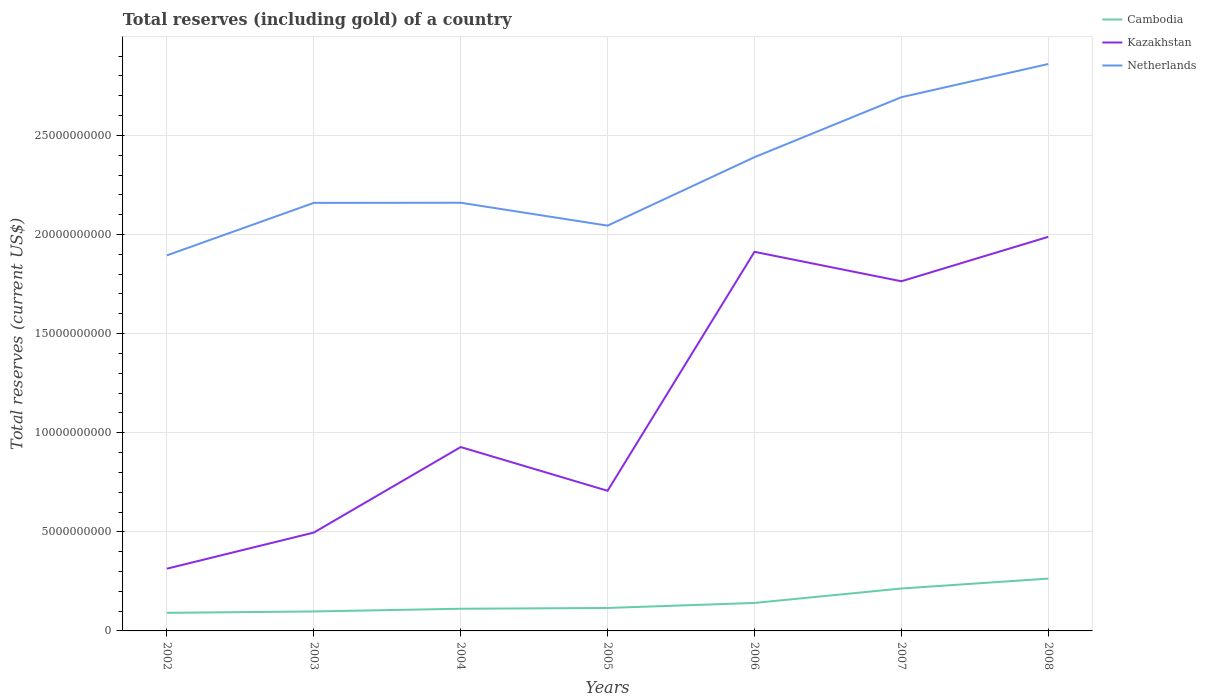How many different coloured lines are there?
Keep it short and to the point. 3. Does the line corresponding to Cambodia intersect with the line corresponding to Netherlands?
Offer a very short reply. No. Across all years, what is the maximum total reserves (including gold) in Kazakhstan?
Keep it short and to the point. 3.14e+09. What is the total total reserves (including gold) in Cambodia in the graph?
Offer a terse response. -2.93e+08. What is the difference between the highest and the second highest total reserves (including gold) in Kazakhstan?
Provide a succinct answer. 1.67e+1. What is the difference between the highest and the lowest total reserves (including gold) in Netherlands?
Give a very brief answer. 3. How many years are there in the graph?
Make the answer very short. 7. What is the difference between two consecutive major ticks on the Y-axis?
Offer a very short reply. 5.00e+09. Are the values on the major ticks of Y-axis written in scientific E-notation?
Offer a very short reply. No. Where does the legend appear in the graph?
Offer a terse response. Top right. What is the title of the graph?
Keep it short and to the point. Total reserves (including gold) of a country. Does "Barbados" appear as one of the legend labels in the graph?
Provide a succinct answer. No. What is the label or title of the X-axis?
Offer a terse response. Years. What is the label or title of the Y-axis?
Your answer should be compact. Total reserves (current US$). What is the Total reserves (current US$) in Cambodia in 2002?
Your response must be concise. 9.13e+08. What is the Total reserves (current US$) of Kazakhstan in 2002?
Keep it short and to the point. 3.14e+09. What is the Total reserves (current US$) in Netherlands in 2002?
Offer a terse response. 1.89e+1. What is the Total reserves (current US$) in Cambodia in 2003?
Your answer should be compact. 9.82e+08. What is the Total reserves (current US$) of Kazakhstan in 2003?
Your answer should be compact. 4.96e+09. What is the Total reserves (current US$) of Netherlands in 2003?
Your answer should be compact. 2.16e+1. What is the Total reserves (current US$) in Cambodia in 2004?
Provide a succinct answer. 1.12e+09. What is the Total reserves (current US$) of Kazakhstan in 2004?
Offer a very short reply. 9.28e+09. What is the Total reserves (current US$) in Netherlands in 2004?
Provide a short and direct response. 2.16e+1. What is the Total reserves (current US$) in Cambodia in 2005?
Make the answer very short. 1.16e+09. What is the Total reserves (current US$) of Kazakhstan in 2005?
Give a very brief answer. 7.07e+09. What is the Total reserves (current US$) of Netherlands in 2005?
Keep it short and to the point. 2.04e+1. What is the Total reserves (current US$) of Cambodia in 2006?
Give a very brief answer. 1.41e+09. What is the Total reserves (current US$) in Kazakhstan in 2006?
Your answer should be very brief. 1.91e+1. What is the Total reserves (current US$) in Netherlands in 2006?
Your answer should be very brief. 2.39e+1. What is the Total reserves (current US$) in Cambodia in 2007?
Make the answer very short. 2.14e+09. What is the Total reserves (current US$) of Kazakhstan in 2007?
Provide a succinct answer. 1.76e+1. What is the Total reserves (current US$) in Netherlands in 2007?
Your answer should be very brief. 2.69e+1. What is the Total reserves (current US$) in Cambodia in 2008?
Keep it short and to the point. 2.64e+09. What is the Total reserves (current US$) of Kazakhstan in 2008?
Ensure brevity in your answer.  1.99e+1. What is the Total reserves (current US$) of Netherlands in 2008?
Your response must be concise. 2.86e+1. Across all years, what is the maximum Total reserves (current US$) in Cambodia?
Provide a short and direct response. 2.64e+09. Across all years, what is the maximum Total reserves (current US$) in Kazakhstan?
Make the answer very short. 1.99e+1. Across all years, what is the maximum Total reserves (current US$) of Netherlands?
Give a very brief answer. 2.86e+1. Across all years, what is the minimum Total reserves (current US$) of Cambodia?
Offer a very short reply. 9.13e+08. Across all years, what is the minimum Total reserves (current US$) of Kazakhstan?
Your answer should be very brief. 3.14e+09. Across all years, what is the minimum Total reserves (current US$) in Netherlands?
Keep it short and to the point. 1.89e+1. What is the total Total reserves (current US$) of Cambodia in the graph?
Your answer should be very brief. 1.04e+1. What is the total Total reserves (current US$) of Kazakhstan in the graph?
Keep it short and to the point. 8.11e+1. What is the total Total reserves (current US$) of Netherlands in the graph?
Keep it short and to the point. 1.62e+11. What is the difference between the Total reserves (current US$) of Cambodia in 2002 and that in 2003?
Keep it short and to the point. -6.92e+07. What is the difference between the Total reserves (current US$) in Kazakhstan in 2002 and that in 2003?
Provide a short and direct response. -1.82e+09. What is the difference between the Total reserves (current US$) of Netherlands in 2002 and that in 2003?
Give a very brief answer. -2.65e+09. What is the difference between the Total reserves (current US$) in Cambodia in 2002 and that in 2004?
Ensure brevity in your answer.  -2.05e+08. What is the difference between the Total reserves (current US$) in Kazakhstan in 2002 and that in 2004?
Provide a succinct answer. -6.14e+09. What is the difference between the Total reserves (current US$) in Netherlands in 2002 and that in 2004?
Your answer should be compact. -2.65e+09. What is the difference between the Total reserves (current US$) of Cambodia in 2002 and that in 2005?
Provide a succinct answer. -2.45e+08. What is the difference between the Total reserves (current US$) in Kazakhstan in 2002 and that in 2005?
Offer a very short reply. -3.93e+09. What is the difference between the Total reserves (current US$) in Netherlands in 2002 and that in 2005?
Offer a terse response. -1.50e+09. What is the difference between the Total reserves (current US$) of Cambodia in 2002 and that in 2006?
Your answer should be very brief. -4.98e+08. What is the difference between the Total reserves (current US$) of Kazakhstan in 2002 and that in 2006?
Offer a very short reply. -1.60e+1. What is the difference between the Total reserves (current US$) of Netherlands in 2002 and that in 2006?
Provide a short and direct response. -4.95e+09. What is the difference between the Total reserves (current US$) of Cambodia in 2002 and that in 2007?
Provide a succinct answer. -1.23e+09. What is the difference between the Total reserves (current US$) of Kazakhstan in 2002 and that in 2007?
Provide a short and direct response. -1.45e+1. What is the difference between the Total reserves (current US$) in Netherlands in 2002 and that in 2007?
Provide a succinct answer. -7.98e+09. What is the difference between the Total reserves (current US$) in Cambodia in 2002 and that in 2008?
Provide a succinct answer. -1.73e+09. What is the difference between the Total reserves (current US$) of Kazakhstan in 2002 and that in 2008?
Your answer should be compact. -1.67e+1. What is the difference between the Total reserves (current US$) in Netherlands in 2002 and that in 2008?
Provide a succinct answer. -9.65e+09. What is the difference between the Total reserves (current US$) in Cambodia in 2003 and that in 2004?
Your response must be concise. -1.36e+08. What is the difference between the Total reserves (current US$) in Kazakhstan in 2003 and that in 2004?
Provide a short and direct response. -4.31e+09. What is the difference between the Total reserves (current US$) of Netherlands in 2003 and that in 2004?
Your answer should be very brief. -6.46e+06. What is the difference between the Total reserves (current US$) in Cambodia in 2003 and that in 2005?
Your response must be concise. -1.76e+08. What is the difference between the Total reserves (current US$) in Kazakhstan in 2003 and that in 2005?
Offer a terse response. -2.11e+09. What is the difference between the Total reserves (current US$) in Netherlands in 2003 and that in 2005?
Keep it short and to the point. 1.15e+09. What is the difference between the Total reserves (current US$) in Cambodia in 2003 and that in 2006?
Offer a very short reply. -4.29e+08. What is the difference between the Total reserves (current US$) of Kazakhstan in 2003 and that in 2006?
Give a very brief answer. -1.42e+1. What is the difference between the Total reserves (current US$) of Netherlands in 2003 and that in 2006?
Offer a very short reply. -2.31e+09. What is the difference between the Total reserves (current US$) of Cambodia in 2003 and that in 2007?
Your answer should be compact. -1.16e+09. What is the difference between the Total reserves (current US$) of Kazakhstan in 2003 and that in 2007?
Provide a succinct answer. -1.27e+1. What is the difference between the Total reserves (current US$) in Netherlands in 2003 and that in 2007?
Ensure brevity in your answer.  -5.33e+09. What is the difference between the Total reserves (current US$) of Cambodia in 2003 and that in 2008?
Make the answer very short. -1.66e+09. What is the difference between the Total reserves (current US$) of Kazakhstan in 2003 and that in 2008?
Offer a very short reply. -1.49e+1. What is the difference between the Total reserves (current US$) in Netherlands in 2003 and that in 2008?
Provide a succinct answer. -7.01e+09. What is the difference between the Total reserves (current US$) in Cambodia in 2004 and that in 2005?
Keep it short and to the point. -3.98e+07. What is the difference between the Total reserves (current US$) in Kazakhstan in 2004 and that in 2005?
Keep it short and to the point. 2.21e+09. What is the difference between the Total reserves (current US$) in Netherlands in 2004 and that in 2005?
Provide a short and direct response. 1.16e+09. What is the difference between the Total reserves (current US$) of Cambodia in 2004 and that in 2006?
Ensure brevity in your answer.  -2.93e+08. What is the difference between the Total reserves (current US$) in Kazakhstan in 2004 and that in 2006?
Make the answer very short. -9.85e+09. What is the difference between the Total reserves (current US$) in Netherlands in 2004 and that in 2006?
Ensure brevity in your answer.  -2.30e+09. What is the difference between the Total reserves (current US$) in Cambodia in 2004 and that in 2007?
Your response must be concise. -1.02e+09. What is the difference between the Total reserves (current US$) of Kazakhstan in 2004 and that in 2007?
Your answer should be compact. -8.36e+09. What is the difference between the Total reserves (current US$) in Netherlands in 2004 and that in 2007?
Provide a succinct answer. -5.32e+09. What is the difference between the Total reserves (current US$) of Cambodia in 2004 and that in 2008?
Provide a succinct answer. -1.52e+09. What is the difference between the Total reserves (current US$) in Kazakhstan in 2004 and that in 2008?
Offer a very short reply. -1.06e+1. What is the difference between the Total reserves (current US$) in Netherlands in 2004 and that in 2008?
Offer a very short reply. -7.00e+09. What is the difference between the Total reserves (current US$) of Cambodia in 2005 and that in 2006?
Your answer should be very brief. -2.53e+08. What is the difference between the Total reserves (current US$) in Kazakhstan in 2005 and that in 2006?
Offer a terse response. -1.21e+1. What is the difference between the Total reserves (current US$) in Netherlands in 2005 and that in 2006?
Make the answer very short. -3.45e+09. What is the difference between the Total reserves (current US$) in Cambodia in 2005 and that in 2007?
Give a very brief answer. -9.82e+08. What is the difference between the Total reserves (current US$) in Kazakhstan in 2005 and that in 2007?
Ensure brevity in your answer.  -1.06e+1. What is the difference between the Total reserves (current US$) of Netherlands in 2005 and that in 2007?
Provide a short and direct response. -6.48e+09. What is the difference between the Total reserves (current US$) in Cambodia in 2005 and that in 2008?
Provide a short and direct response. -1.48e+09. What is the difference between the Total reserves (current US$) in Kazakhstan in 2005 and that in 2008?
Your answer should be very brief. -1.28e+1. What is the difference between the Total reserves (current US$) of Netherlands in 2005 and that in 2008?
Make the answer very short. -8.15e+09. What is the difference between the Total reserves (current US$) of Cambodia in 2006 and that in 2007?
Offer a very short reply. -7.29e+08. What is the difference between the Total reserves (current US$) of Kazakhstan in 2006 and that in 2007?
Your answer should be compact. 1.49e+09. What is the difference between the Total reserves (current US$) of Netherlands in 2006 and that in 2007?
Make the answer very short. -3.03e+09. What is the difference between the Total reserves (current US$) of Cambodia in 2006 and that in 2008?
Your answer should be compact. -1.23e+09. What is the difference between the Total reserves (current US$) in Kazakhstan in 2006 and that in 2008?
Offer a terse response. -7.56e+08. What is the difference between the Total reserves (current US$) in Netherlands in 2006 and that in 2008?
Your response must be concise. -4.70e+09. What is the difference between the Total reserves (current US$) of Cambodia in 2007 and that in 2008?
Give a very brief answer. -4.99e+08. What is the difference between the Total reserves (current US$) of Kazakhstan in 2007 and that in 2008?
Offer a very short reply. -2.24e+09. What is the difference between the Total reserves (current US$) in Netherlands in 2007 and that in 2008?
Provide a succinct answer. -1.67e+09. What is the difference between the Total reserves (current US$) in Cambodia in 2002 and the Total reserves (current US$) in Kazakhstan in 2003?
Offer a very short reply. -4.05e+09. What is the difference between the Total reserves (current US$) of Cambodia in 2002 and the Total reserves (current US$) of Netherlands in 2003?
Your answer should be very brief. -2.07e+1. What is the difference between the Total reserves (current US$) in Kazakhstan in 2002 and the Total reserves (current US$) in Netherlands in 2003?
Your response must be concise. -1.85e+1. What is the difference between the Total reserves (current US$) of Cambodia in 2002 and the Total reserves (current US$) of Kazakhstan in 2004?
Provide a succinct answer. -8.36e+09. What is the difference between the Total reserves (current US$) in Cambodia in 2002 and the Total reserves (current US$) in Netherlands in 2004?
Make the answer very short. -2.07e+1. What is the difference between the Total reserves (current US$) of Kazakhstan in 2002 and the Total reserves (current US$) of Netherlands in 2004?
Offer a terse response. -1.85e+1. What is the difference between the Total reserves (current US$) of Cambodia in 2002 and the Total reserves (current US$) of Kazakhstan in 2005?
Make the answer very short. -6.16e+09. What is the difference between the Total reserves (current US$) in Cambodia in 2002 and the Total reserves (current US$) in Netherlands in 2005?
Your answer should be compact. -1.95e+1. What is the difference between the Total reserves (current US$) of Kazakhstan in 2002 and the Total reserves (current US$) of Netherlands in 2005?
Your answer should be compact. -1.73e+1. What is the difference between the Total reserves (current US$) in Cambodia in 2002 and the Total reserves (current US$) in Kazakhstan in 2006?
Make the answer very short. -1.82e+1. What is the difference between the Total reserves (current US$) in Cambodia in 2002 and the Total reserves (current US$) in Netherlands in 2006?
Offer a terse response. -2.30e+1. What is the difference between the Total reserves (current US$) in Kazakhstan in 2002 and the Total reserves (current US$) in Netherlands in 2006?
Offer a very short reply. -2.08e+1. What is the difference between the Total reserves (current US$) in Cambodia in 2002 and the Total reserves (current US$) in Kazakhstan in 2007?
Ensure brevity in your answer.  -1.67e+1. What is the difference between the Total reserves (current US$) of Cambodia in 2002 and the Total reserves (current US$) of Netherlands in 2007?
Ensure brevity in your answer.  -2.60e+1. What is the difference between the Total reserves (current US$) of Kazakhstan in 2002 and the Total reserves (current US$) of Netherlands in 2007?
Provide a short and direct response. -2.38e+1. What is the difference between the Total reserves (current US$) in Cambodia in 2002 and the Total reserves (current US$) in Kazakhstan in 2008?
Give a very brief answer. -1.90e+1. What is the difference between the Total reserves (current US$) in Cambodia in 2002 and the Total reserves (current US$) in Netherlands in 2008?
Your response must be concise. -2.77e+1. What is the difference between the Total reserves (current US$) of Kazakhstan in 2002 and the Total reserves (current US$) of Netherlands in 2008?
Give a very brief answer. -2.55e+1. What is the difference between the Total reserves (current US$) of Cambodia in 2003 and the Total reserves (current US$) of Kazakhstan in 2004?
Offer a terse response. -8.29e+09. What is the difference between the Total reserves (current US$) in Cambodia in 2003 and the Total reserves (current US$) in Netherlands in 2004?
Make the answer very short. -2.06e+1. What is the difference between the Total reserves (current US$) of Kazakhstan in 2003 and the Total reserves (current US$) of Netherlands in 2004?
Ensure brevity in your answer.  -1.66e+1. What is the difference between the Total reserves (current US$) of Cambodia in 2003 and the Total reserves (current US$) of Kazakhstan in 2005?
Provide a short and direct response. -6.09e+09. What is the difference between the Total reserves (current US$) in Cambodia in 2003 and the Total reserves (current US$) in Netherlands in 2005?
Ensure brevity in your answer.  -1.95e+1. What is the difference between the Total reserves (current US$) of Kazakhstan in 2003 and the Total reserves (current US$) of Netherlands in 2005?
Keep it short and to the point. -1.55e+1. What is the difference between the Total reserves (current US$) in Cambodia in 2003 and the Total reserves (current US$) in Kazakhstan in 2006?
Offer a very short reply. -1.81e+1. What is the difference between the Total reserves (current US$) in Cambodia in 2003 and the Total reserves (current US$) in Netherlands in 2006?
Your answer should be very brief. -2.29e+1. What is the difference between the Total reserves (current US$) in Kazakhstan in 2003 and the Total reserves (current US$) in Netherlands in 2006?
Offer a very short reply. -1.89e+1. What is the difference between the Total reserves (current US$) in Cambodia in 2003 and the Total reserves (current US$) in Kazakhstan in 2007?
Provide a short and direct response. -1.67e+1. What is the difference between the Total reserves (current US$) of Cambodia in 2003 and the Total reserves (current US$) of Netherlands in 2007?
Offer a very short reply. -2.59e+1. What is the difference between the Total reserves (current US$) in Kazakhstan in 2003 and the Total reserves (current US$) in Netherlands in 2007?
Give a very brief answer. -2.20e+1. What is the difference between the Total reserves (current US$) in Cambodia in 2003 and the Total reserves (current US$) in Kazakhstan in 2008?
Make the answer very short. -1.89e+1. What is the difference between the Total reserves (current US$) of Cambodia in 2003 and the Total reserves (current US$) of Netherlands in 2008?
Provide a short and direct response. -2.76e+1. What is the difference between the Total reserves (current US$) in Kazakhstan in 2003 and the Total reserves (current US$) in Netherlands in 2008?
Ensure brevity in your answer.  -2.36e+1. What is the difference between the Total reserves (current US$) in Cambodia in 2004 and the Total reserves (current US$) in Kazakhstan in 2005?
Make the answer very short. -5.95e+09. What is the difference between the Total reserves (current US$) in Cambodia in 2004 and the Total reserves (current US$) in Netherlands in 2005?
Your response must be concise. -1.93e+1. What is the difference between the Total reserves (current US$) of Kazakhstan in 2004 and the Total reserves (current US$) of Netherlands in 2005?
Ensure brevity in your answer.  -1.12e+1. What is the difference between the Total reserves (current US$) in Cambodia in 2004 and the Total reserves (current US$) in Kazakhstan in 2006?
Provide a succinct answer. -1.80e+1. What is the difference between the Total reserves (current US$) in Cambodia in 2004 and the Total reserves (current US$) in Netherlands in 2006?
Offer a terse response. -2.28e+1. What is the difference between the Total reserves (current US$) of Kazakhstan in 2004 and the Total reserves (current US$) of Netherlands in 2006?
Offer a very short reply. -1.46e+1. What is the difference between the Total reserves (current US$) of Cambodia in 2004 and the Total reserves (current US$) of Kazakhstan in 2007?
Make the answer very short. -1.65e+1. What is the difference between the Total reserves (current US$) in Cambodia in 2004 and the Total reserves (current US$) in Netherlands in 2007?
Your response must be concise. -2.58e+1. What is the difference between the Total reserves (current US$) of Kazakhstan in 2004 and the Total reserves (current US$) of Netherlands in 2007?
Make the answer very short. -1.77e+1. What is the difference between the Total reserves (current US$) of Cambodia in 2004 and the Total reserves (current US$) of Kazakhstan in 2008?
Give a very brief answer. -1.88e+1. What is the difference between the Total reserves (current US$) of Cambodia in 2004 and the Total reserves (current US$) of Netherlands in 2008?
Offer a very short reply. -2.75e+1. What is the difference between the Total reserves (current US$) in Kazakhstan in 2004 and the Total reserves (current US$) in Netherlands in 2008?
Your response must be concise. -1.93e+1. What is the difference between the Total reserves (current US$) in Cambodia in 2005 and the Total reserves (current US$) in Kazakhstan in 2006?
Offer a very short reply. -1.80e+1. What is the difference between the Total reserves (current US$) of Cambodia in 2005 and the Total reserves (current US$) of Netherlands in 2006?
Your answer should be compact. -2.27e+1. What is the difference between the Total reserves (current US$) in Kazakhstan in 2005 and the Total reserves (current US$) in Netherlands in 2006?
Ensure brevity in your answer.  -1.68e+1. What is the difference between the Total reserves (current US$) in Cambodia in 2005 and the Total reserves (current US$) in Kazakhstan in 2007?
Offer a very short reply. -1.65e+1. What is the difference between the Total reserves (current US$) of Cambodia in 2005 and the Total reserves (current US$) of Netherlands in 2007?
Your answer should be compact. -2.58e+1. What is the difference between the Total reserves (current US$) in Kazakhstan in 2005 and the Total reserves (current US$) in Netherlands in 2007?
Make the answer very short. -1.99e+1. What is the difference between the Total reserves (current US$) in Cambodia in 2005 and the Total reserves (current US$) in Kazakhstan in 2008?
Offer a very short reply. -1.87e+1. What is the difference between the Total reserves (current US$) in Cambodia in 2005 and the Total reserves (current US$) in Netherlands in 2008?
Provide a succinct answer. -2.74e+1. What is the difference between the Total reserves (current US$) of Kazakhstan in 2005 and the Total reserves (current US$) of Netherlands in 2008?
Keep it short and to the point. -2.15e+1. What is the difference between the Total reserves (current US$) in Cambodia in 2006 and the Total reserves (current US$) in Kazakhstan in 2007?
Provide a short and direct response. -1.62e+1. What is the difference between the Total reserves (current US$) in Cambodia in 2006 and the Total reserves (current US$) in Netherlands in 2007?
Make the answer very short. -2.55e+1. What is the difference between the Total reserves (current US$) in Kazakhstan in 2006 and the Total reserves (current US$) in Netherlands in 2007?
Provide a short and direct response. -7.80e+09. What is the difference between the Total reserves (current US$) in Cambodia in 2006 and the Total reserves (current US$) in Kazakhstan in 2008?
Offer a very short reply. -1.85e+1. What is the difference between the Total reserves (current US$) of Cambodia in 2006 and the Total reserves (current US$) of Netherlands in 2008?
Keep it short and to the point. -2.72e+1. What is the difference between the Total reserves (current US$) of Kazakhstan in 2006 and the Total reserves (current US$) of Netherlands in 2008?
Give a very brief answer. -9.48e+09. What is the difference between the Total reserves (current US$) in Cambodia in 2007 and the Total reserves (current US$) in Kazakhstan in 2008?
Give a very brief answer. -1.77e+1. What is the difference between the Total reserves (current US$) in Cambodia in 2007 and the Total reserves (current US$) in Netherlands in 2008?
Keep it short and to the point. -2.65e+1. What is the difference between the Total reserves (current US$) in Kazakhstan in 2007 and the Total reserves (current US$) in Netherlands in 2008?
Your response must be concise. -1.10e+1. What is the average Total reserves (current US$) in Cambodia per year?
Your response must be concise. 1.48e+09. What is the average Total reserves (current US$) in Kazakhstan per year?
Provide a short and direct response. 1.16e+1. What is the average Total reserves (current US$) of Netherlands per year?
Provide a succinct answer. 2.31e+1. In the year 2002, what is the difference between the Total reserves (current US$) in Cambodia and Total reserves (current US$) in Kazakhstan?
Give a very brief answer. -2.23e+09. In the year 2002, what is the difference between the Total reserves (current US$) of Cambodia and Total reserves (current US$) of Netherlands?
Provide a short and direct response. -1.80e+1. In the year 2002, what is the difference between the Total reserves (current US$) of Kazakhstan and Total reserves (current US$) of Netherlands?
Your answer should be very brief. -1.58e+1. In the year 2003, what is the difference between the Total reserves (current US$) of Cambodia and Total reserves (current US$) of Kazakhstan?
Ensure brevity in your answer.  -3.98e+09. In the year 2003, what is the difference between the Total reserves (current US$) of Cambodia and Total reserves (current US$) of Netherlands?
Make the answer very short. -2.06e+1. In the year 2003, what is the difference between the Total reserves (current US$) in Kazakhstan and Total reserves (current US$) in Netherlands?
Offer a terse response. -1.66e+1. In the year 2004, what is the difference between the Total reserves (current US$) of Cambodia and Total reserves (current US$) of Kazakhstan?
Keep it short and to the point. -8.16e+09. In the year 2004, what is the difference between the Total reserves (current US$) of Cambodia and Total reserves (current US$) of Netherlands?
Ensure brevity in your answer.  -2.05e+1. In the year 2004, what is the difference between the Total reserves (current US$) of Kazakhstan and Total reserves (current US$) of Netherlands?
Give a very brief answer. -1.23e+1. In the year 2005, what is the difference between the Total reserves (current US$) in Cambodia and Total reserves (current US$) in Kazakhstan?
Provide a succinct answer. -5.91e+09. In the year 2005, what is the difference between the Total reserves (current US$) of Cambodia and Total reserves (current US$) of Netherlands?
Ensure brevity in your answer.  -1.93e+1. In the year 2005, what is the difference between the Total reserves (current US$) in Kazakhstan and Total reserves (current US$) in Netherlands?
Provide a succinct answer. -1.34e+1. In the year 2006, what is the difference between the Total reserves (current US$) in Cambodia and Total reserves (current US$) in Kazakhstan?
Give a very brief answer. -1.77e+1. In the year 2006, what is the difference between the Total reserves (current US$) of Cambodia and Total reserves (current US$) of Netherlands?
Ensure brevity in your answer.  -2.25e+1. In the year 2006, what is the difference between the Total reserves (current US$) in Kazakhstan and Total reserves (current US$) in Netherlands?
Provide a short and direct response. -4.78e+09. In the year 2007, what is the difference between the Total reserves (current US$) of Cambodia and Total reserves (current US$) of Kazakhstan?
Keep it short and to the point. -1.55e+1. In the year 2007, what is the difference between the Total reserves (current US$) in Cambodia and Total reserves (current US$) in Netherlands?
Provide a short and direct response. -2.48e+1. In the year 2007, what is the difference between the Total reserves (current US$) of Kazakhstan and Total reserves (current US$) of Netherlands?
Ensure brevity in your answer.  -9.29e+09. In the year 2008, what is the difference between the Total reserves (current US$) in Cambodia and Total reserves (current US$) in Kazakhstan?
Give a very brief answer. -1.72e+1. In the year 2008, what is the difference between the Total reserves (current US$) in Cambodia and Total reserves (current US$) in Netherlands?
Your answer should be very brief. -2.60e+1. In the year 2008, what is the difference between the Total reserves (current US$) of Kazakhstan and Total reserves (current US$) of Netherlands?
Your response must be concise. -8.72e+09. What is the ratio of the Total reserves (current US$) in Cambodia in 2002 to that in 2003?
Offer a terse response. 0.93. What is the ratio of the Total reserves (current US$) in Kazakhstan in 2002 to that in 2003?
Your answer should be very brief. 0.63. What is the ratio of the Total reserves (current US$) in Netherlands in 2002 to that in 2003?
Offer a terse response. 0.88. What is the ratio of the Total reserves (current US$) in Cambodia in 2002 to that in 2004?
Ensure brevity in your answer.  0.82. What is the ratio of the Total reserves (current US$) of Kazakhstan in 2002 to that in 2004?
Provide a succinct answer. 0.34. What is the ratio of the Total reserves (current US$) of Netherlands in 2002 to that in 2004?
Your answer should be very brief. 0.88. What is the ratio of the Total reserves (current US$) of Cambodia in 2002 to that in 2005?
Ensure brevity in your answer.  0.79. What is the ratio of the Total reserves (current US$) in Kazakhstan in 2002 to that in 2005?
Provide a short and direct response. 0.44. What is the ratio of the Total reserves (current US$) in Netherlands in 2002 to that in 2005?
Provide a short and direct response. 0.93. What is the ratio of the Total reserves (current US$) of Cambodia in 2002 to that in 2006?
Ensure brevity in your answer.  0.65. What is the ratio of the Total reserves (current US$) in Kazakhstan in 2002 to that in 2006?
Offer a terse response. 0.16. What is the ratio of the Total reserves (current US$) in Netherlands in 2002 to that in 2006?
Provide a short and direct response. 0.79. What is the ratio of the Total reserves (current US$) in Cambodia in 2002 to that in 2007?
Ensure brevity in your answer.  0.43. What is the ratio of the Total reserves (current US$) in Kazakhstan in 2002 to that in 2007?
Your response must be concise. 0.18. What is the ratio of the Total reserves (current US$) in Netherlands in 2002 to that in 2007?
Keep it short and to the point. 0.7. What is the ratio of the Total reserves (current US$) of Cambodia in 2002 to that in 2008?
Make the answer very short. 0.35. What is the ratio of the Total reserves (current US$) of Kazakhstan in 2002 to that in 2008?
Keep it short and to the point. 0.16. What is the ratio of the Total reserves (current US$) of Netherlands in 2002 to that in 2008?
Your answer should be very brief. 0.66. What is the ratio of the Total reserves (current US$) in Cambodia in 2003 to that in 2004?
Provide a succinct answer. 0.88. What is the ratio of the Total reserves (current US$) in Kazakhstan in 2003 to that in 2004?
Give a very brief answer. 0.53. What is the ratio of the Total reserves (current US$) in Cambodia in 2003 to that in 2005?
Provide a succinct answer. 0.85. What is the ratio of the Total reserves (current US$) of Kazakhstan in 2003 to that in 2005?
Provide a short and direct response. 0.7. What is the ratio of the Total reserves (current US$) of Netherlands in 2003 to that in 2005?
Your response must be concise. 1.06. What is the ratio of the Total reserves (current US$) of Cambodia in 2003 to that in 2006?
Provide a succinct answer. 0.7. What is the ratio of the Total reserves (current US$) of Kazakhstan in 2003 to that in 2006?
Offer a terse response. 0.26. What is the ratio of the Total reserves (current US$) of Netherlands in 2003 to that in 2006?
Provide a succinct answer. 0.9. What is the ratio of the Total reserves (current US$) of Cambodia in 2003 to that in 2007?
Offer a terse response. 0.46. What is the ratio of the Total reserves (current US$) in Kazakhstan in 2003 to that in 2007?
Offer a very short reply. 0.28. What is the ratio of the Total reserves (current US$) of Netherlands in 2003 to that in 2007?
Provide a succinct answer. 0.8. What is the ratio of the Total reserves (current US$) in Cambodia in 2003 to that in 2008?
Make the answer very short. 0.37. What is the ratio of the Total reserves (current US$) in Kazakhstan in 2003 to that in 2008?
Your answer should be very brief. 0.25. What is the ratio of the Total reserves (current US$) in Netherlands in 2003 to that in 2008?
Your response must be concise. 0.76. What is the ratio of the Total reserves (current US$) in Cambodia in 2004 to that in 2005?
Ensure brevity in your answer.  0.97. What is the ratio of the Total reserves (current US$) in Kazakhstan in 2004 to that in 2005?
Ensure brevity in your answer.  1.31. What is the ratio of the Total reserves (current US$) in Netherlands in 2004 to that in 2005?
Keep it short and to the point. 1.06. What is the ratio of the Total reserves (current US$) in Cambodia in 2004 to that in 2006?
Give a very brief answer. 0.79. What is the ratio of the Total reserves (current US$) of Kazakhstan in 2004 to that in 2006?
Make the answer very short. 0.48. What is the ratio of the Total reserves (current US$) in Netherlands in 2004 to that in 2006?
Your response must be concise. 0.9. What is the ratio of the Total reserves (current US$) of Cambodia in 2004 to that in 2007?
Provide a short and direct response. 0.52. What is the ratio of the Total reserves (current US$) in Kazakhstan in 2004 to that in 2007?
Provide a succinct answer. 0.53. What is the ratio of the Total reserves (current US$) in Netherlands in 2004 to that in 2007?
Offer a terse response. 0.8. What is the ratio of the Total reserves (current US$) of Cambodia in 2004 to that in 2008?
Make the answer very short. 0.42. What is the ratio of the Total reserves (current US$) of Kazakhstan in 2004 to that in 2008?
Make the answer very short. 0.47. What is the ratio of the Total reserves (current US$) of Netherlands in 2004 to that in 2008?
Your answer should be compact. 0.76. What is the ratio of the Total reserves (current US$) in Cambodia in 2005 to that in 2006?
Your answer should be very brief. 0.82. What is the ratio of the Total reserves (current US$) in Kazakhstan in 2005 to that in 2006?
Make the answer very short. 0.37. What is the ratio of the Total reserves (current US$) in Netherlands in 2005 to that in 2006?
Your response must be concise. 0.86. What is the ratio of the Total reserves (current US$) in Cambodia in 2005 to that in 2007?
Ensure brevity in your answer.  0.54. What is the ratio of the Total reserves (current US$) of Kazakhstan in 2005 to that in 2007?
Your response must be concise. 0.4. What is the ratio of the Total reserves (current US$) in Netherlands in 2005 to that in 2007?
Your answer should be very brief. 0.76. What is the ratio of the Total reserves (current US$) of Cambodia in 2005 to that in 2008?
Offer a very short reply. 0.44. What is the ratio of the Total reserves (current US$) in Kazakhstan in 2005 to that in 2008?
Provide a short and direct response. 0.36. What is the ratio of the Total reserves (current US$) of Netherlands in 2005 to that in 2008?
Provide a short and direct response. 0.71. What is the ratio of the Total reserves (current US$) in Cambodia in 2006 to that in 2007?
Offer a very short reply. 0.66. What is the ratio of the Total reserves (current US$) in Kazakhstan in 2006 to that in 2007?
Give a very brief answer. 1.08. What is the ratio of the Total reserves (current US$) in Netherlands in 2006 to that in 2007?
Ensure brevity in your answer.  0.89. What is the ratio of the Total reserves (current US$) of Cambodia in 2006 to that in 2008?
Your response must be concise. 0.53. What is the ratio of the Total reserves (current US$) of Netherlands in 2006 to that in 2008?
Keep it short and to the point. 0.84. What is the ratio of the Total reserves (current US$) of Cambodia in 2007 to that in 2008?
Give a very brief answer. 0.81. What is the ratio of the Total reserves (current US$) in Kazakhstan in 2007 to that in 2008?
Your response must be concise. 0.89. What is the ratio of the Total reserves (current US$) of Netherlands in 2007 to that in 2008?
Your response must be concise. 0.94. What is the difference between the highest and the second highest Total reserves (current US$) in Cambodia?
Offer a terse response. 4.99e+08. What is the difference between the highest and the second highest Total reserves (current US$) of Kazakhstan?
Make the answer very short. 7.56e+08. What is the difference between the highest and the second highest Total reserves (current US$) in Netherlands?
Ensure brevity in your answer.  1.67e+09. What is the difference between the highest and the lowest Total reserves (current US$) in Cambodia?
Keep it short and to the point. 1.73e+09. What is the difference between the highest and the lowest Total reserves (current US$) of Kazakhstan?
Your response must be concise. 1.67e+1. What is the difference between the highest and the lowest Total reserves (current US$) of Netherlands?
Make the answer very short. 9.65e+09. 